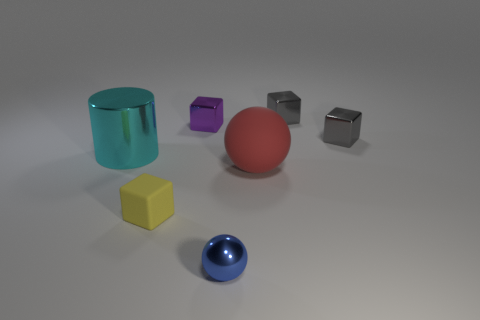Add 2 purple metallic things. How many objects exist? 9 Subtract all cylinders. How many objects are left? 6 Subtract 0 yellow spheres. How many objects are left? 7 Subtract all tiny gray metallic things. Subtract all gray cubes. How many objects are left? 3 Add 4 small blue metal spheres. How many small blue metal spheres are left? 5 Add 3 purple cylinders. How many purple cylinders exist? 3 